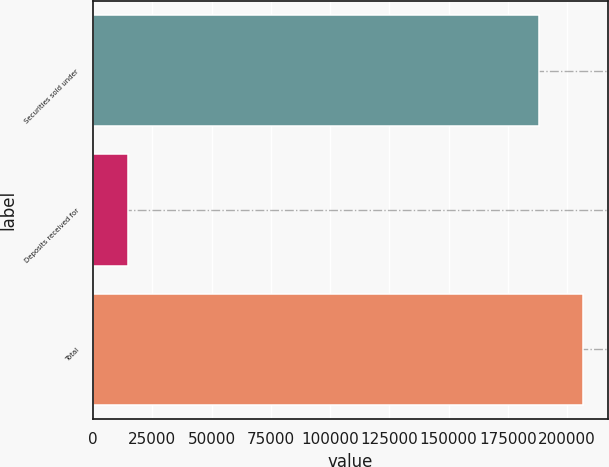<chart> <loc_0><loc_0><loc_500><loc_500><bar_chart><fcel>Securities sold under<fcel>Deposits received for<fcel>Total<nl><fcel>188040<fcel>14657<fcel>206844<nl></chart> 